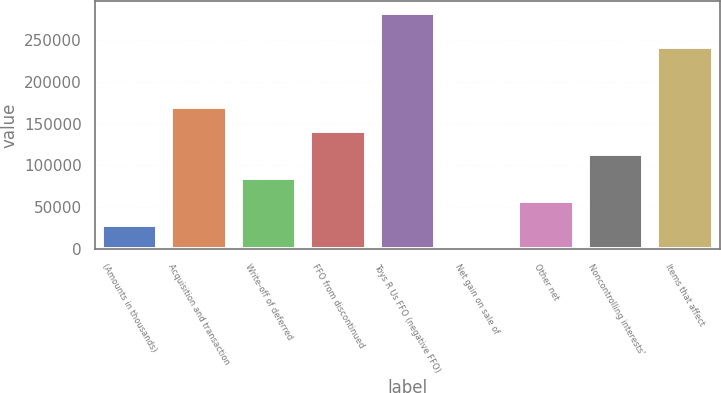Convert chart to OTSL. <chart><loc_0><loc_0><loc_500><loc_500><bar_chart><fcel>(Amounts in thousands)<fcel>Acquisition and transaction<fcel>Write-off of deferred<fcel>FFO from discontinued<fcel>Toys R Us FFO (negative FFO)<fcel>Net gain on sale of<fcel>Other net<fcel>Noncontrolling interests'<fcel>Items that affect<nl><fcel>28637<fcel>169417<fcel>84949<fcel>141261<fcel>282041<fcel>481<fcel>56793<fcel>113105<fcel>241605<nl></chart> 